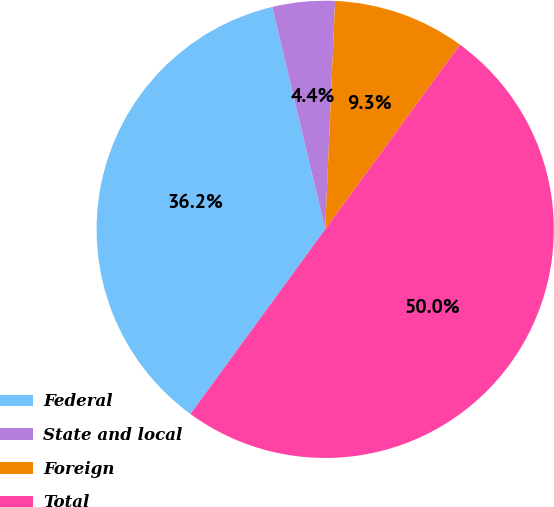Convert chart to OTSL. <chart><loc_0><loc_0><loc_500><loc_500><pie_chart><fcel>Federal<fcel>State and local<fcel>Foreign<fcel>Total<nl><fcel>36.24%<fcel>4.41%<fcel>9.34%<fcel>50.0%<nl></chart> 